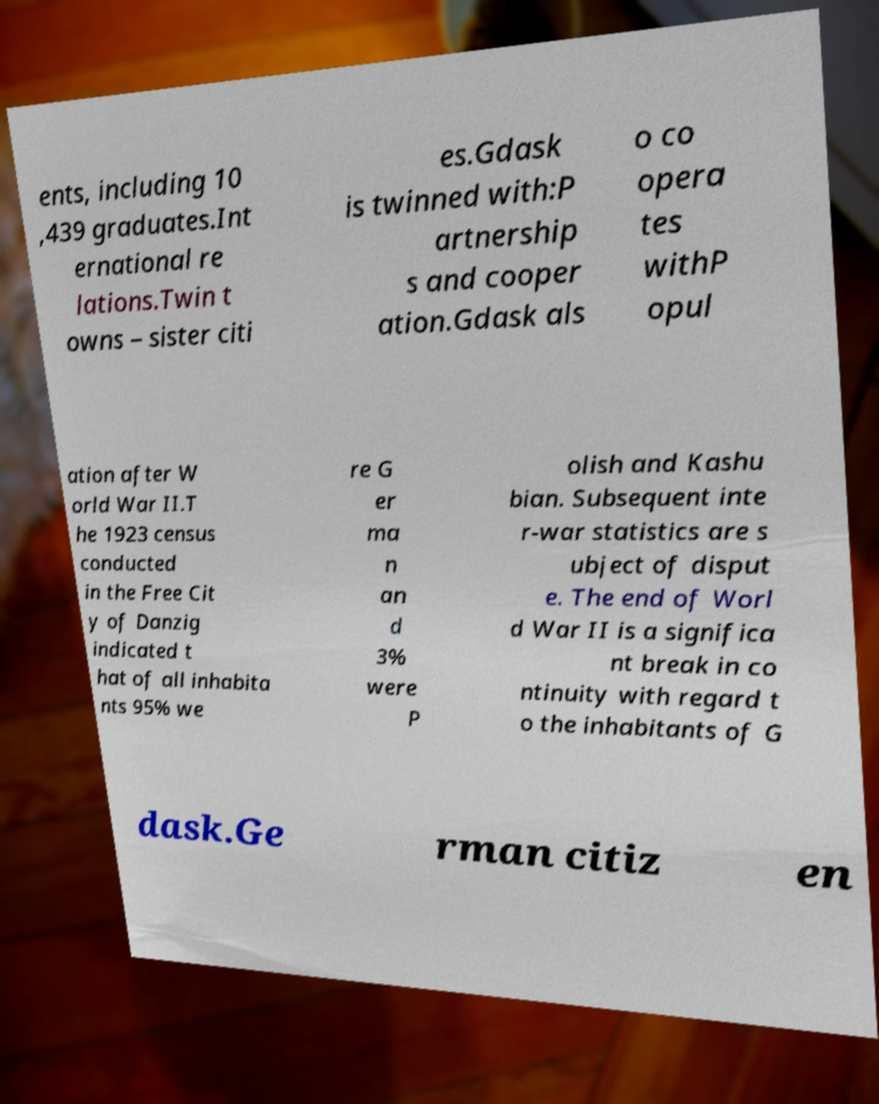Please identify and transcribe the text found in this image. ents, including 10 ,439 graduates.Int ernational re lations.Twin t owns – sister citi es.Gdask is twinned with:P artnership s and cooper ation.Gdask als o co opera tes withP opul ation after W orld War II.T he 1923 census conducted in the Free Cit y of Danzig indicated t hat of all inhabita nts 95% we re G er ma n an d 3% were P olish and Kashu bian. Subsequent inte r-war statistics are s ubject of disput e. The end of Worl d War II is a significa nt break in co ntinuity with regard t o the inhabitants of G dask.Ge rman citiz en 